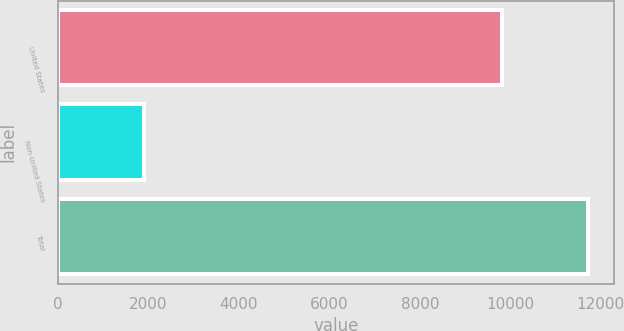Convert chart to OTSL. <chart><loc_0><loc_0><loc_500><loc_500><bar_chart><fcel>United States<fcel>Non-United States<fcel>Total<nl><fcel>9810.6<fcel>1900.7<fcel>11711.3<nl></chart> 